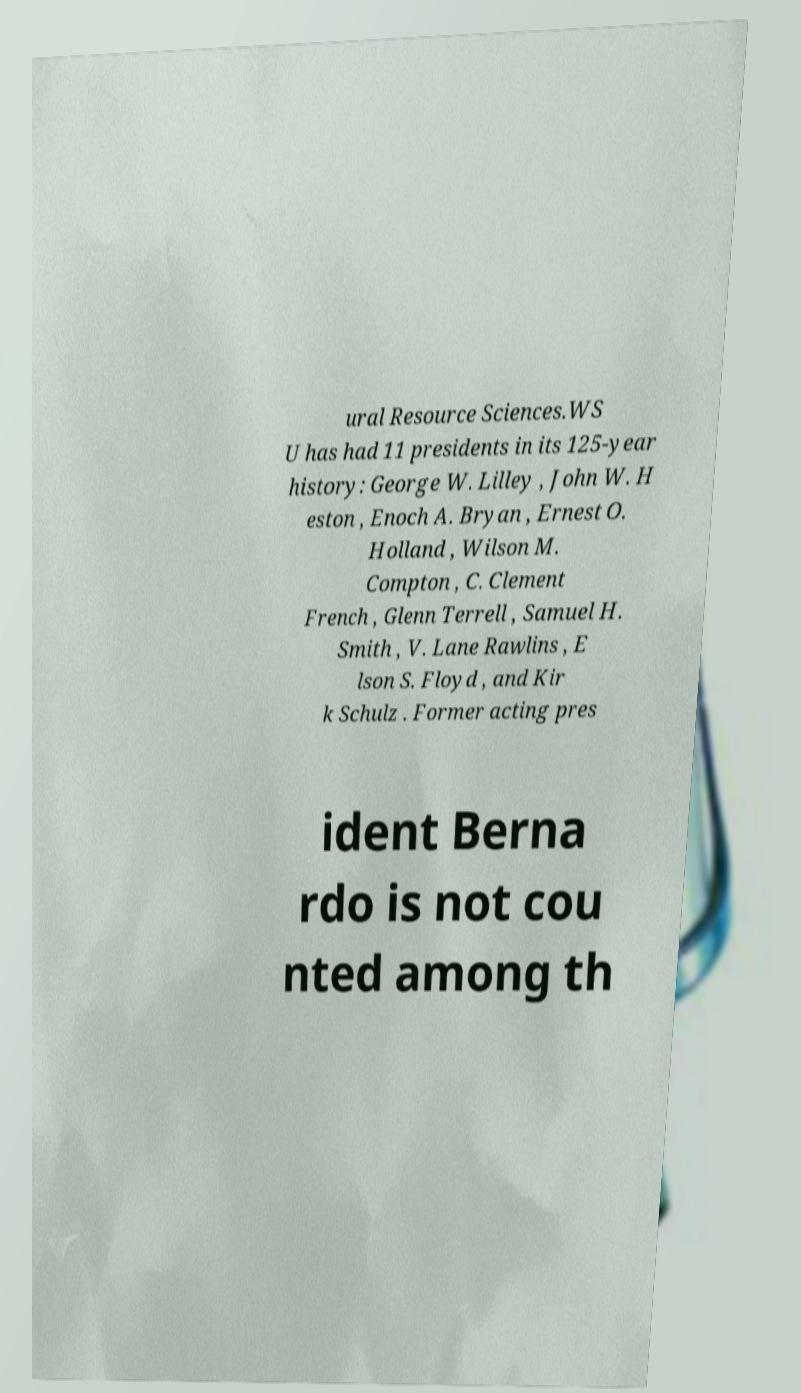Could you assist in decoding the text presented in this image and type it out clearly? ural Resource Sciences.WS U has had 11 presidents in its 125-year history: George W. Lilley , John W. H eston , Enoch A. Bryan , Ernest O. Holland , Wilson M. Compton , C. Clement French , Glenn Terrell , Samuel H. Smith , V. Lane Rawlins , E lson S. Floyd , and Kir k Schulz . Former acting pres ident Berna rdo is not cou nted among th 